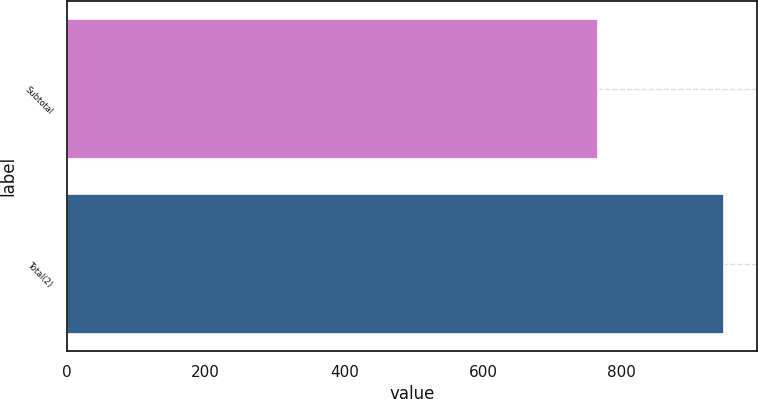Convert chart to OTSL. <chart><loc_0><loc_0><loc_500><loc_500><bar_chart><fcel>Subtotal<fcel>Total(2)<nl><fcel>766<fcel>948<nl></chart> 